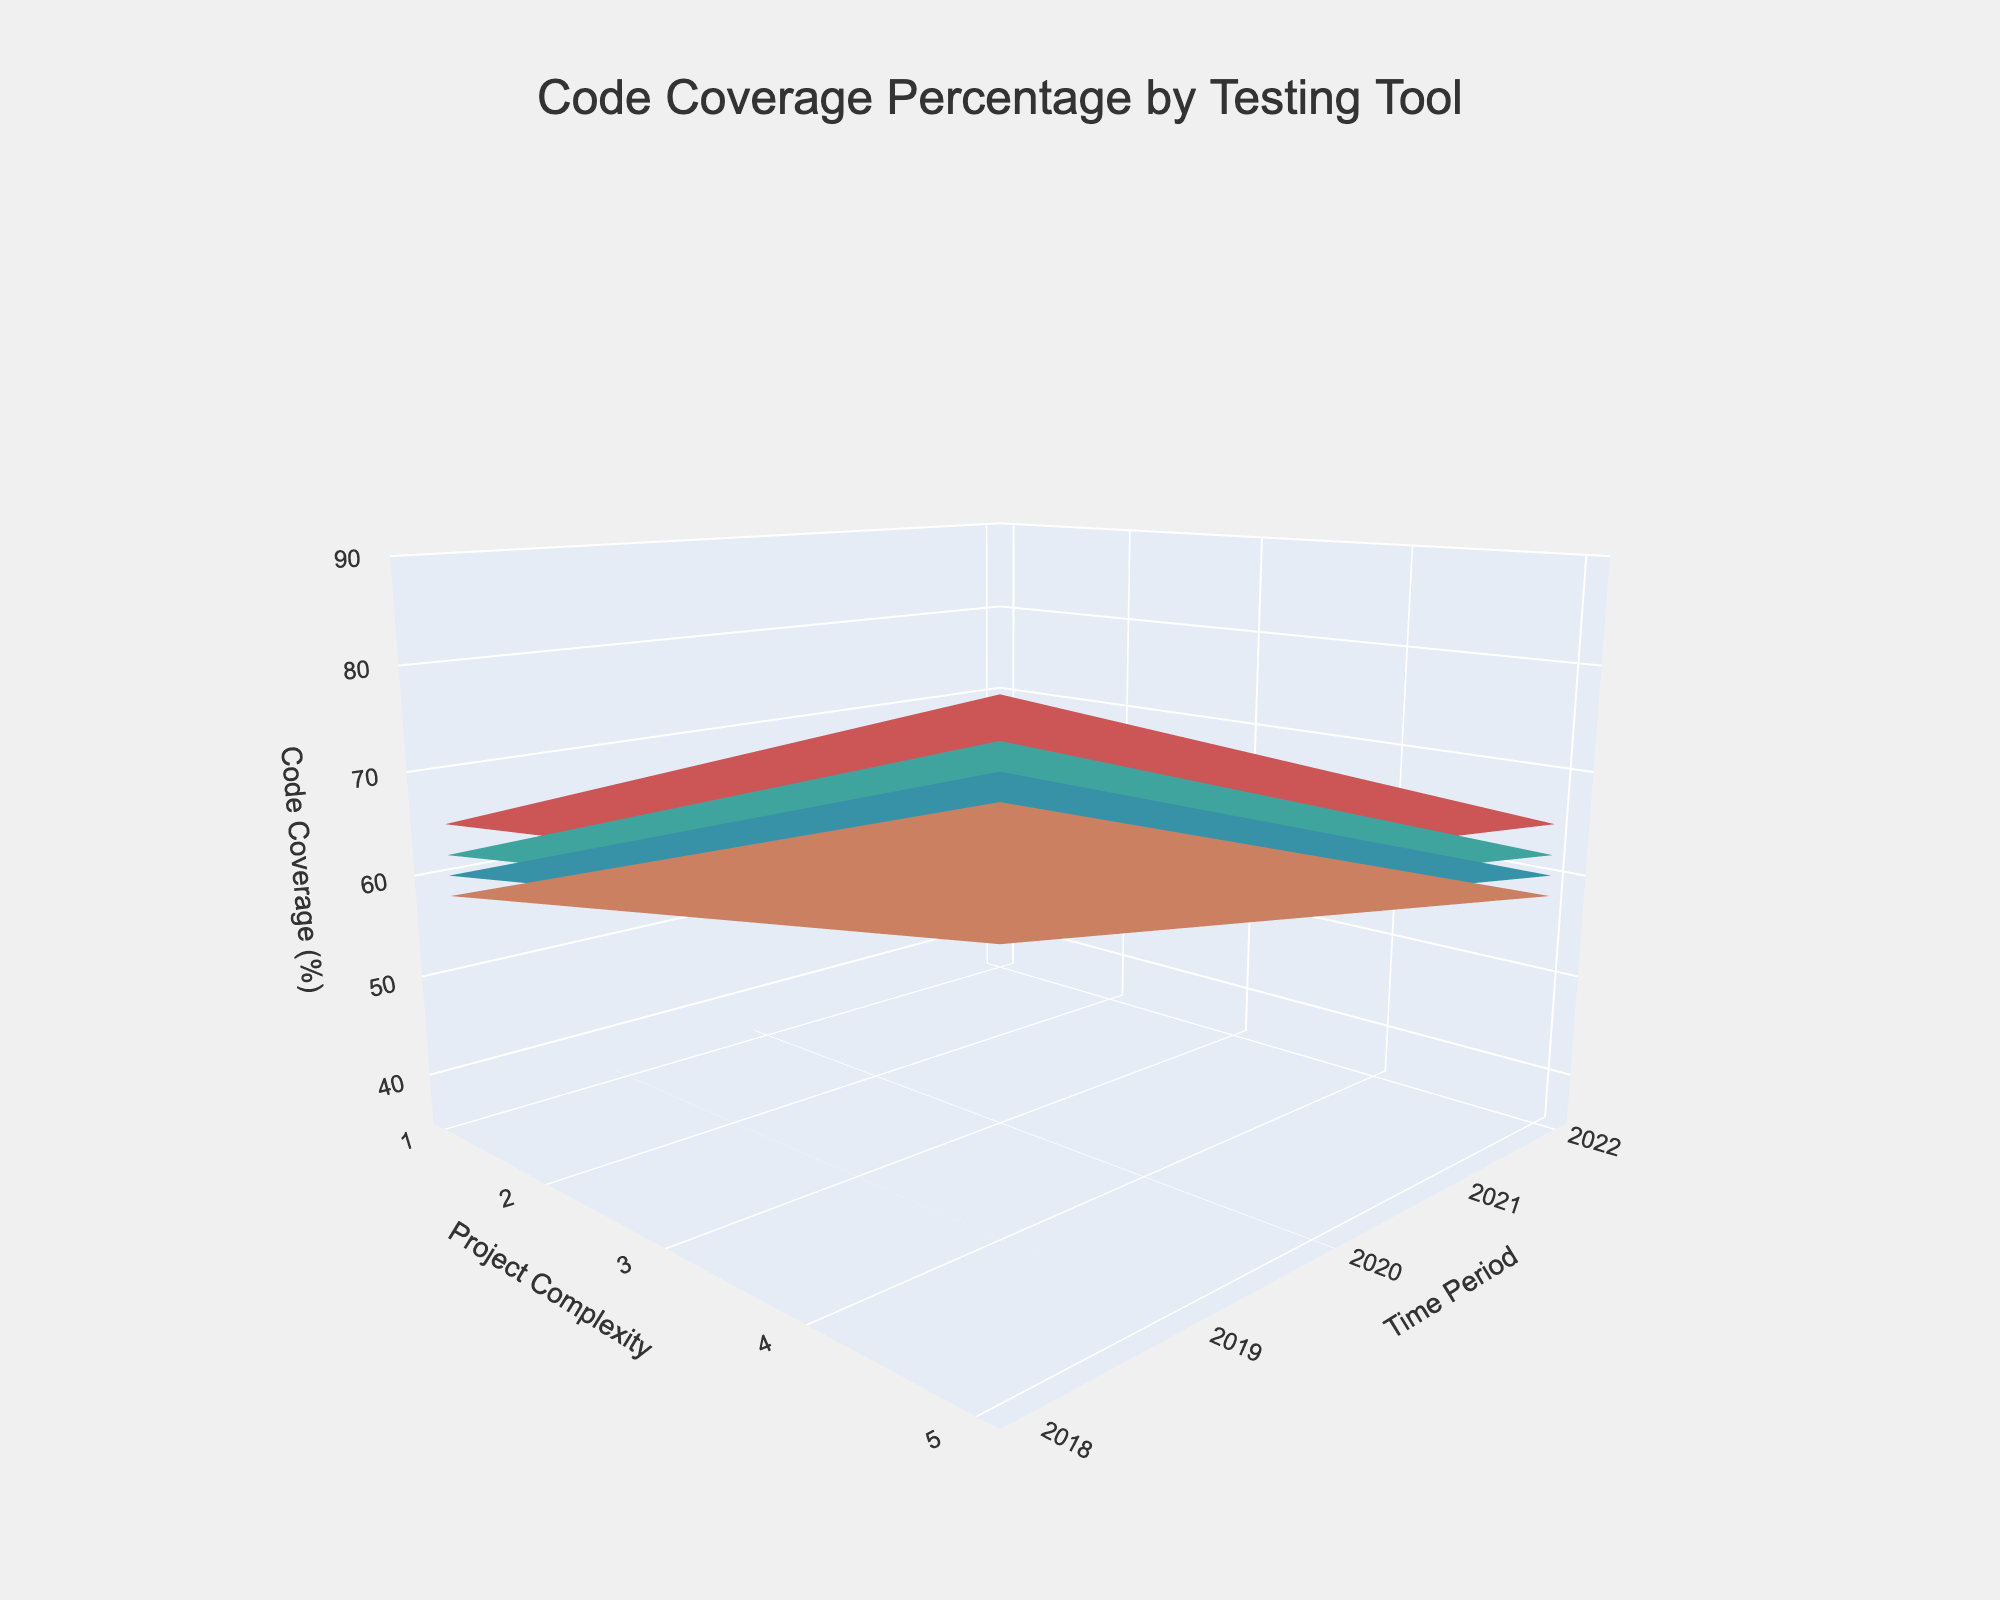What's the title of the figure? The title of the figure is displayed prominently at the top and reads "Code Coverage Percentage by Testing Tool."
Answer: Code Coverage Percentage by Testing Tool What are the axes labels? The labels on the axes can be seen on the figure: the x-axis is labeled "Project Complexity," the y-axis is labeled "Time Period," and the z-axis is labeled "Code Coverage (%)."
Answer: Project Complexity, Time Period, Code Coverage (%) Which testing tool shows the highest code coverage in 2022 for a complexity level of 2? Look at the surface plot for each testing tool in 2022 along the y-axis for the complexity level of 2 on the x-axis. The color for Jest (red) is the highest at this point.
Answer: Jest Compare the code coverage trend for Jest and Jasmine over the years as project complexity increases. For both Jest and Jasmine, the code coverage increases over time. As project complexity increases, both tools still show improvement but Jest consistently has higher coverage than Jasmine. This trend should be evident in the height of the red (Jest) and yellow (Jasmine) surfaces.
Answer: Jest consistently has higher coverage What is the difference in code coverage between 2018 and 2022 for Mocha at a project complexity of 3? For Mocha in 2018 at complexity level 3, the coverage is at 52%. In 2022, it is at 72%. Subtract the two values: 72% - 52% = 20%.
Answer: 20% For which project complexity level and year does Karma have the lowest code coverage? Scan the Karma surface (light orange) and look for the point that is closest to the base. The lowest point is at project complexity 5 in the year 2018.
Answer: Complexity 5 and Year 2018 How does the code coverage for Jasmine change from 2019 to 2020 for a project with complexity 4? At complexity level 4 in 2019, the code coverage for Jasmine is 50%. In 2020, it is 55%. The difference is 55% - 50% = 5%.
Answer: Increases by 5% In which year does Jest achieve at least 70% code coverage for all project complexities? Follow the Jest surface (red section) along the y-axis (years). Jest achieves 70% code coverage or more starting in 2020 across all project complexity levels from 1 to 5.
Answer: 2020 What is the average code coverage in 2020 across all complexities for Mocha? To calculate the average, find Mocha's coverage values for 2020: 72%, 67%, 62%, 57%, 52%. Sum these values and divide by 5: (72 + 67 + 62 + 57 + 52) / 5 = 62%.
Answer: 62% What is the overall trend in code coverage for all tools as time progresses? Observing the surfaces of all tools, they all show an increasing trend in code coverage as the years go from 2018 to 2022, regardless of project complexity.
Answer: Increasing trend 